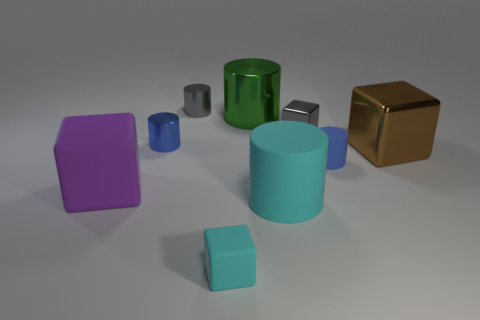There is a purple thing that is the same size as the green shiny thing; what is it made of?
Your response must be concise. Rubber. The tiny cylinder that is in front of the gray shiny cylinder and right of the blue shiny cylinder is made of what material?
Make the answer very short. Rubber. Do the gray block that is behind the blue metallic thing and the tiny gray cylinder have the same size?
Your response must be concise. Yes. There is another small rubber object that is the same shape as the purple thing; what color is it?
Offer a very short reply. Cyan. What shape is the blue thing that is to the left of the gray cube?
Ensure brevity in your answer.  Cylinder. How many small blue metallic objects are the same shape as the big purple rubber object?
Give a very brief answer. 0. Is the color of the large cylinder that is in front of the large purple cube the same as the block in front of the purple object?
Your answer should be very brief. Yes. How many things are either big green matte cylinders or shiny cubes?
Ensure brevity in your answer.  2. How many big green objects are made of the same material as the gray cylinder?
Your answer should be compact. 1. Are there fewer small gray cubes than large cylinders?
Your answer should be very brief. Yes. 